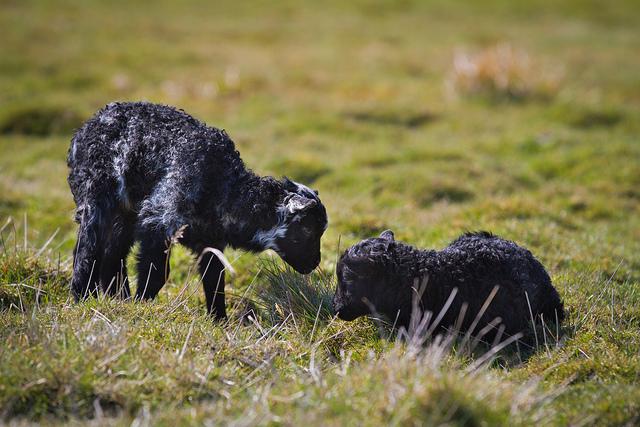Are these animals probably from the same litter?
Give a very brief answer. Yes. What color are these animals?
Keep it brief. Black. What kind of animals are those?
Keep it brief. Sheep. What color is the one different sheep?
Short answer required. Black. Where are these animals located?
Answer briefly. Grass. 